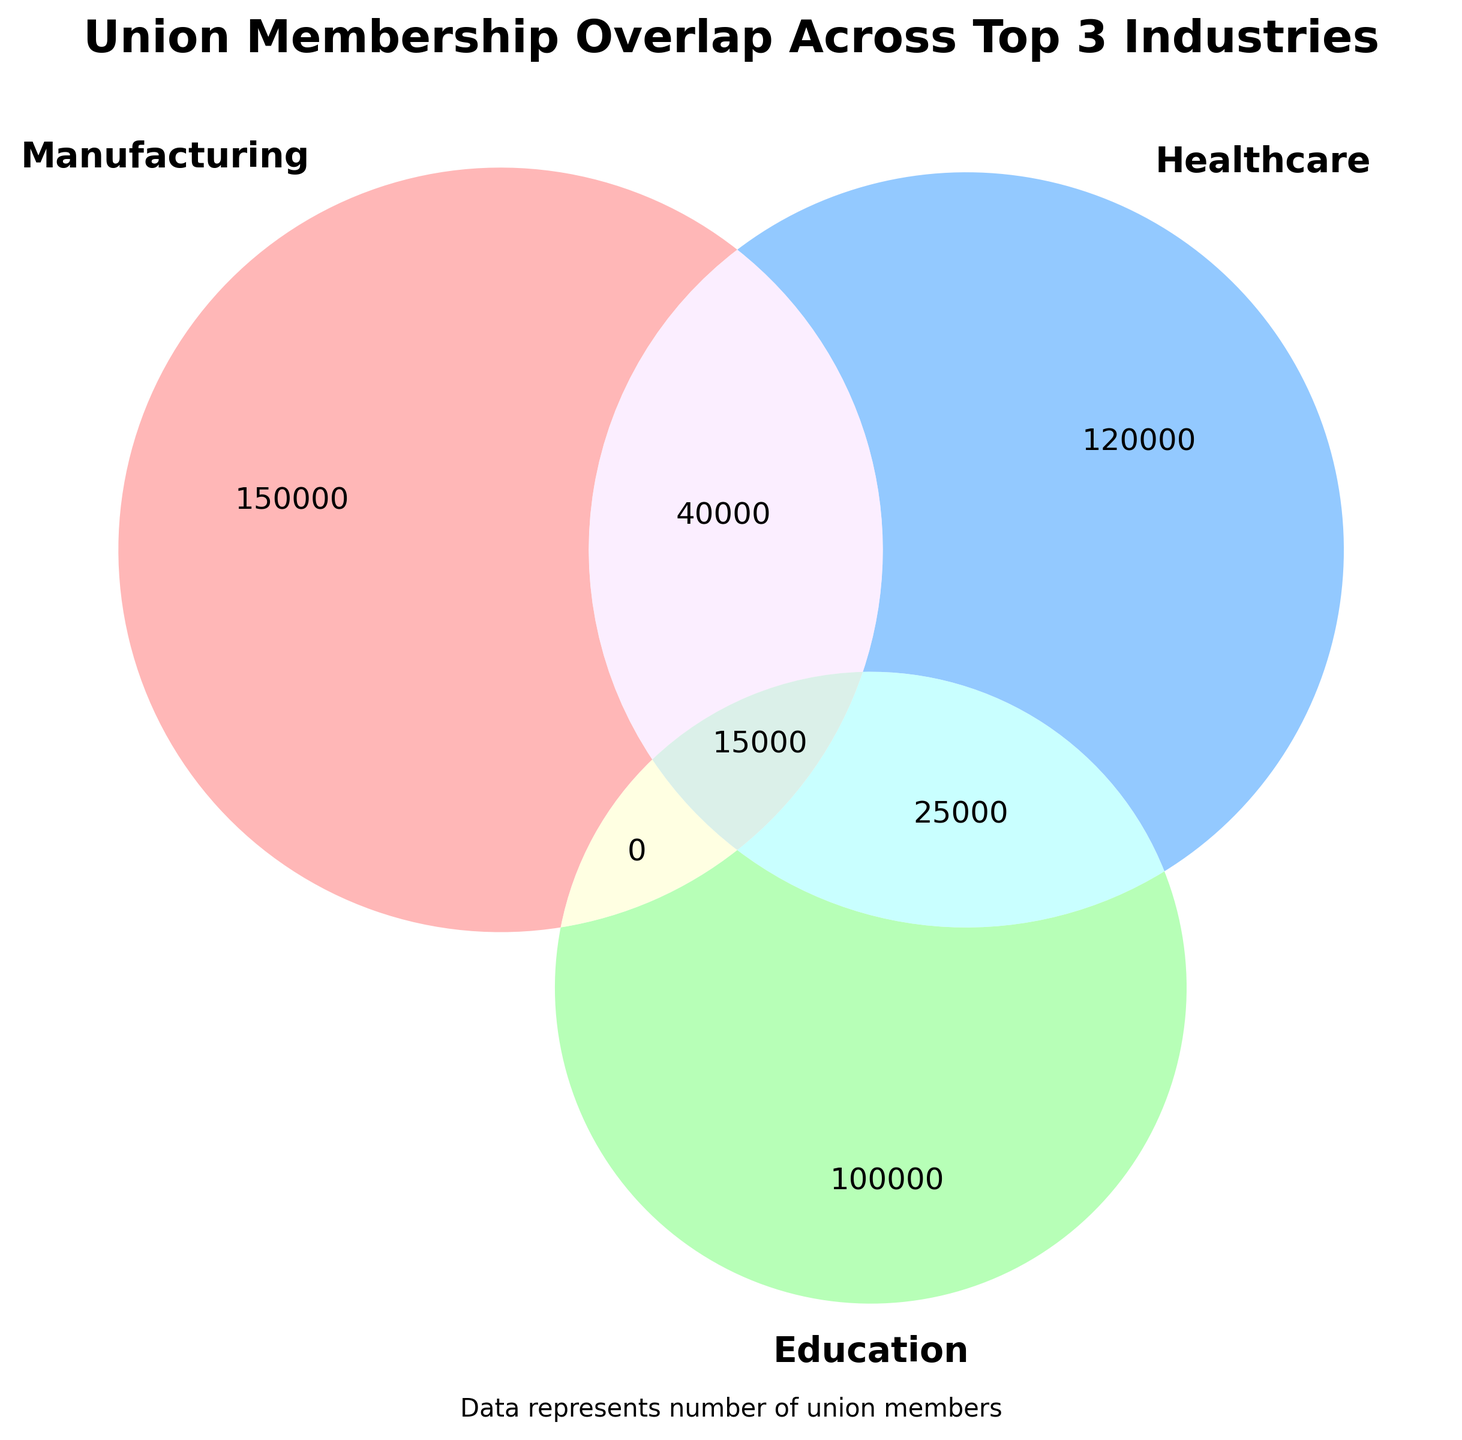How many union members are there in the Healthcare industry? From the Venn diagram, Healthcare is one of the main circles. The number associated with Healthcare alone is 120,000.
Answer: 120,000 How many union members are there who work in both Manufacturing and Healthcare but not in Transportation? The overlap section between Manufacturing and Healthcare but outside Transportation indicates the number 40,000.
Answer: 40,000 What is the combined total of union members in the Healthcare and Education overlap groups alone? The overlap between Healthcare and Education is 25,000, as seen in the intersecting section of the two circles.
Answer: 25,000 How many union members are there in the intersection of all three industries: Manufacturing, Healthcare, and Education? The center section where all three circles intersect shows the number 15,000.
Answer: 15,000 Which industry has the smallest unique number of union members? Examining the Venn diagram, the Education circle alone has 100,000, which is less than both Manufacturing (150,000) and Healthcare (120,000).
Answer: Education Which intersection region between any two industries other than Healthcare and Education has the maximum number of union members? Beyond Healthcare and Education (25,000), Manufacturing and Healthcare have an intersection of 40,000, which is the highest among the others.
Answer: Manufacturing and Healthcare What is the total number of union members in the Manufacturing circle, considering all overlaps? Adding all segments within Manufacturing: 150,000 (alone) + 40,000 (with Healthcare) + 15,000 (with Healthcare and Education) = 205,000.
Answer: 205,000 How many more union members are in the Manufacturing circle compared to the Transportation circle considering all overlaps? The sum for Manufacturing (with overlaps) is 205,000. For Transportation: 80,000 (alone) + 30,000 (with Manufacturing) + 15,000 (with Healthcare and Manufacturing) = 125,000. The difference is 205,000 - 125,000 = 80,000.
Answer: 80,000 